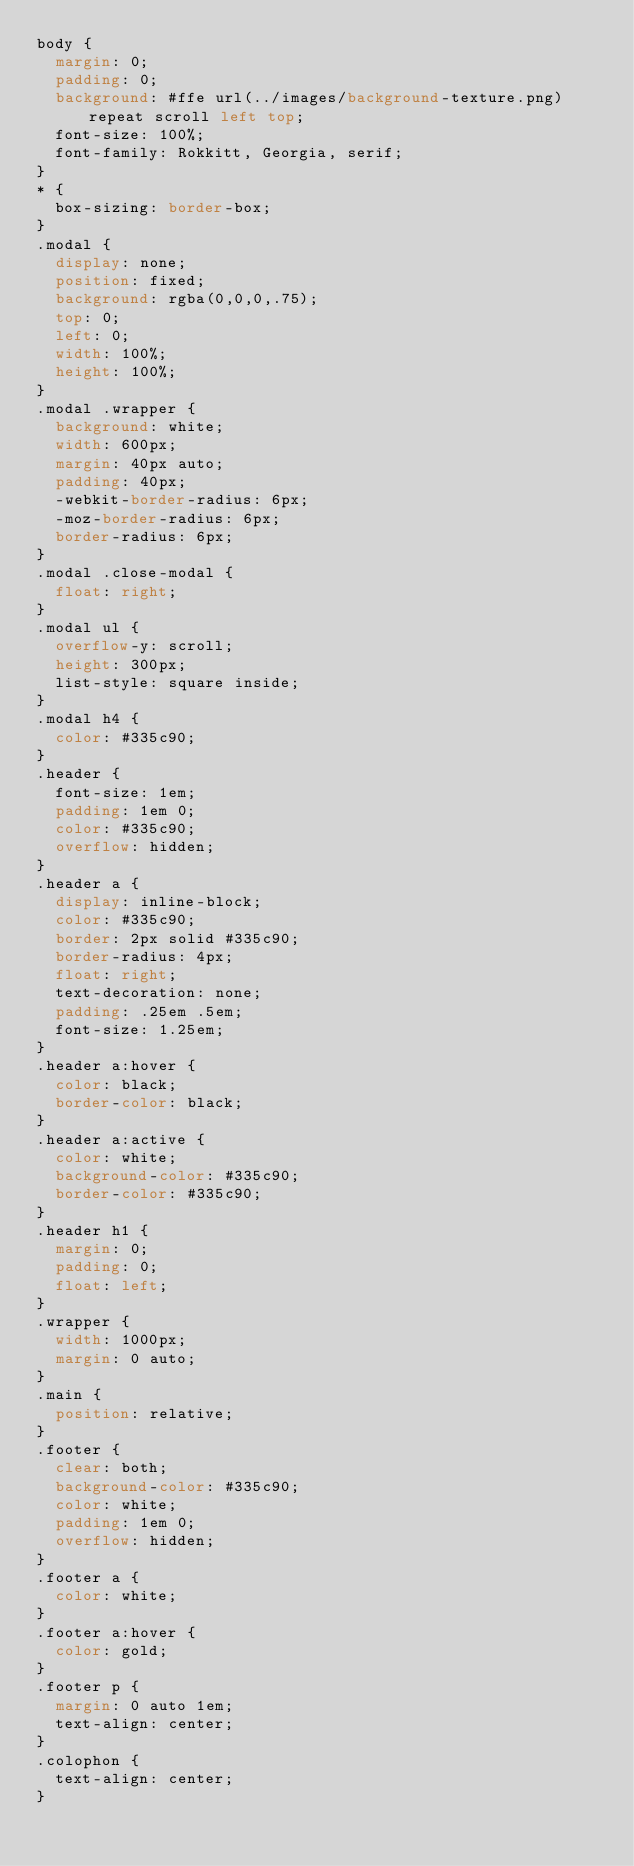<code> <loc_0><loc_0><loc_500><loc_500><_CSS_>body {
  margin: 0;
  padding: 0;
  background: #ffe url(../images/background-texture.png) repeat scroll left top;
  font-size: 100%;
  font-family: Rokkitt, Georgia, serif;
}
* {
  box-sizing: border-box;
}
.modal {
  display: none;
  position: fixed;
  background: rgba(0,0,0,.75);
  top: 0;
  left: 0;
  width: 100%;
  height: 100%;
}
.modal .wrapper {
  background: white;
  width: 600px;
  margin: 40px auto;
  padding: 40px;
  -webkit-border-radius: 6px;
  -moz-border-radius: 6px;
  border-radius: 6px;
}
.modal .close-modal {
  float: right;
}
.modal ul {
  overflow-y: scroll;
  height: 300px;
  list-style: square inside;
}
.modal h4 {
  color: #335c90;
}
.header {
  font-size: 1em;
  padding: 1em 0;
  color: #335c90;
  overflow: hidden;
}
.header a {
  display: inline-block;
  color: #335c90;
  border: 2px solid #335c90;
  border-radius: 4px;
  float: right;
  text-decoration: none;
  padding: .25em .5em;
  font-size: 1.25em;
}
.header a:hover {
  color: black;
  border-color: black;
}
.header a:active {
  color: white;
  background-color: #335c90;
  border-color: #335c90;
}
.header h1 {
  margin: 0;
  padding: 0;
  float: left;
}
.wrapper {
  width: 1000px;
  margin: 0 auto;
}
.main {
  position: relative;
}
.footer {
  clear: both;
  background-color: #335c90;
  color: white;
  padding: 1em 0;
  overflow: hidden;
}
.footer a {
  color: white;
}
.footer a:hover {
  color: gold;
}
.footer p {
  margin: 0 auto 1em;
  text-align: center;
}
.colophon {
  text-align: center;
}</code> 